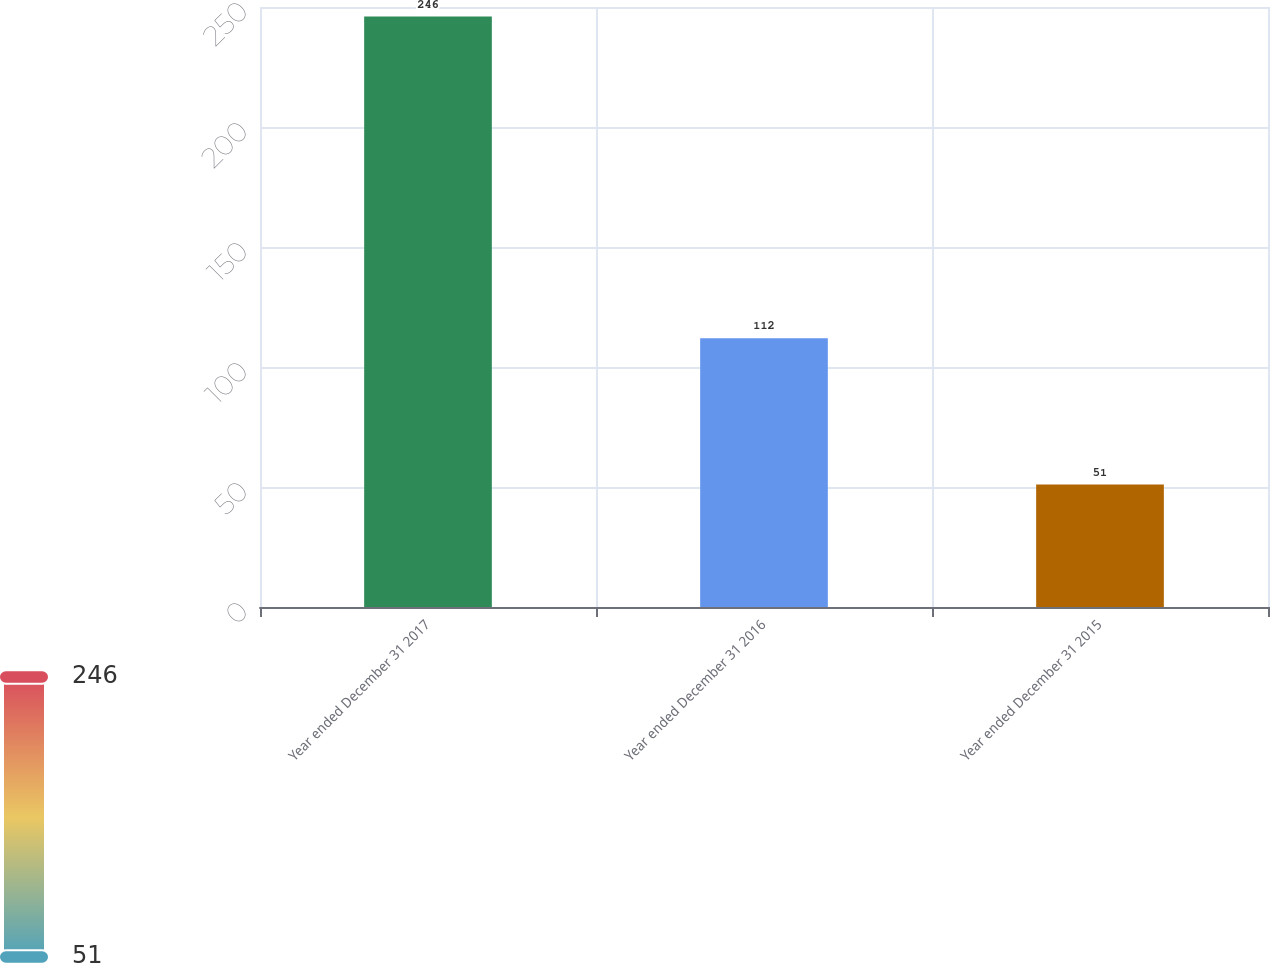Convert chart to OTSL. <chart><loc_0><loc_0><loc_500><loc_500><bar_chart><fcel>Year ended December 31 2017<fcel>Year ended December 31 2016<fcel>Year ended December 31 2015<nl><fcel>246<fcel>112<fcel>51<nl></chart> 